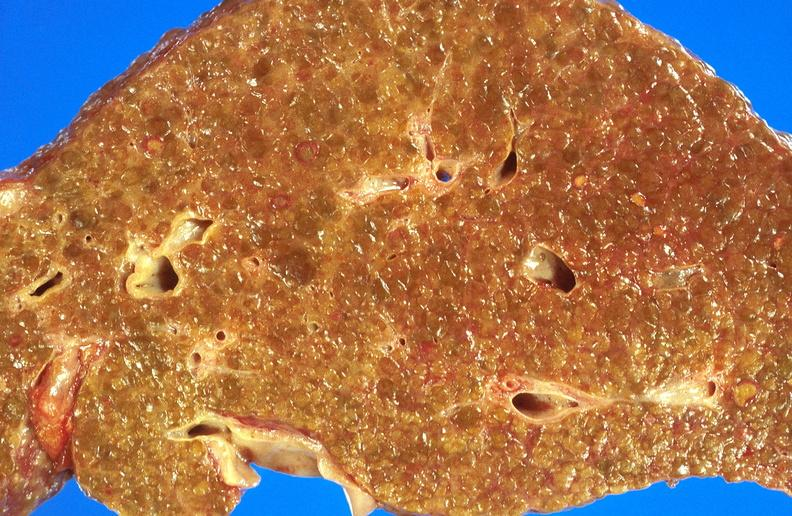s alpha smooth muscle actin immunohistochemical present?
Answer the question using a single word or phrase. No 